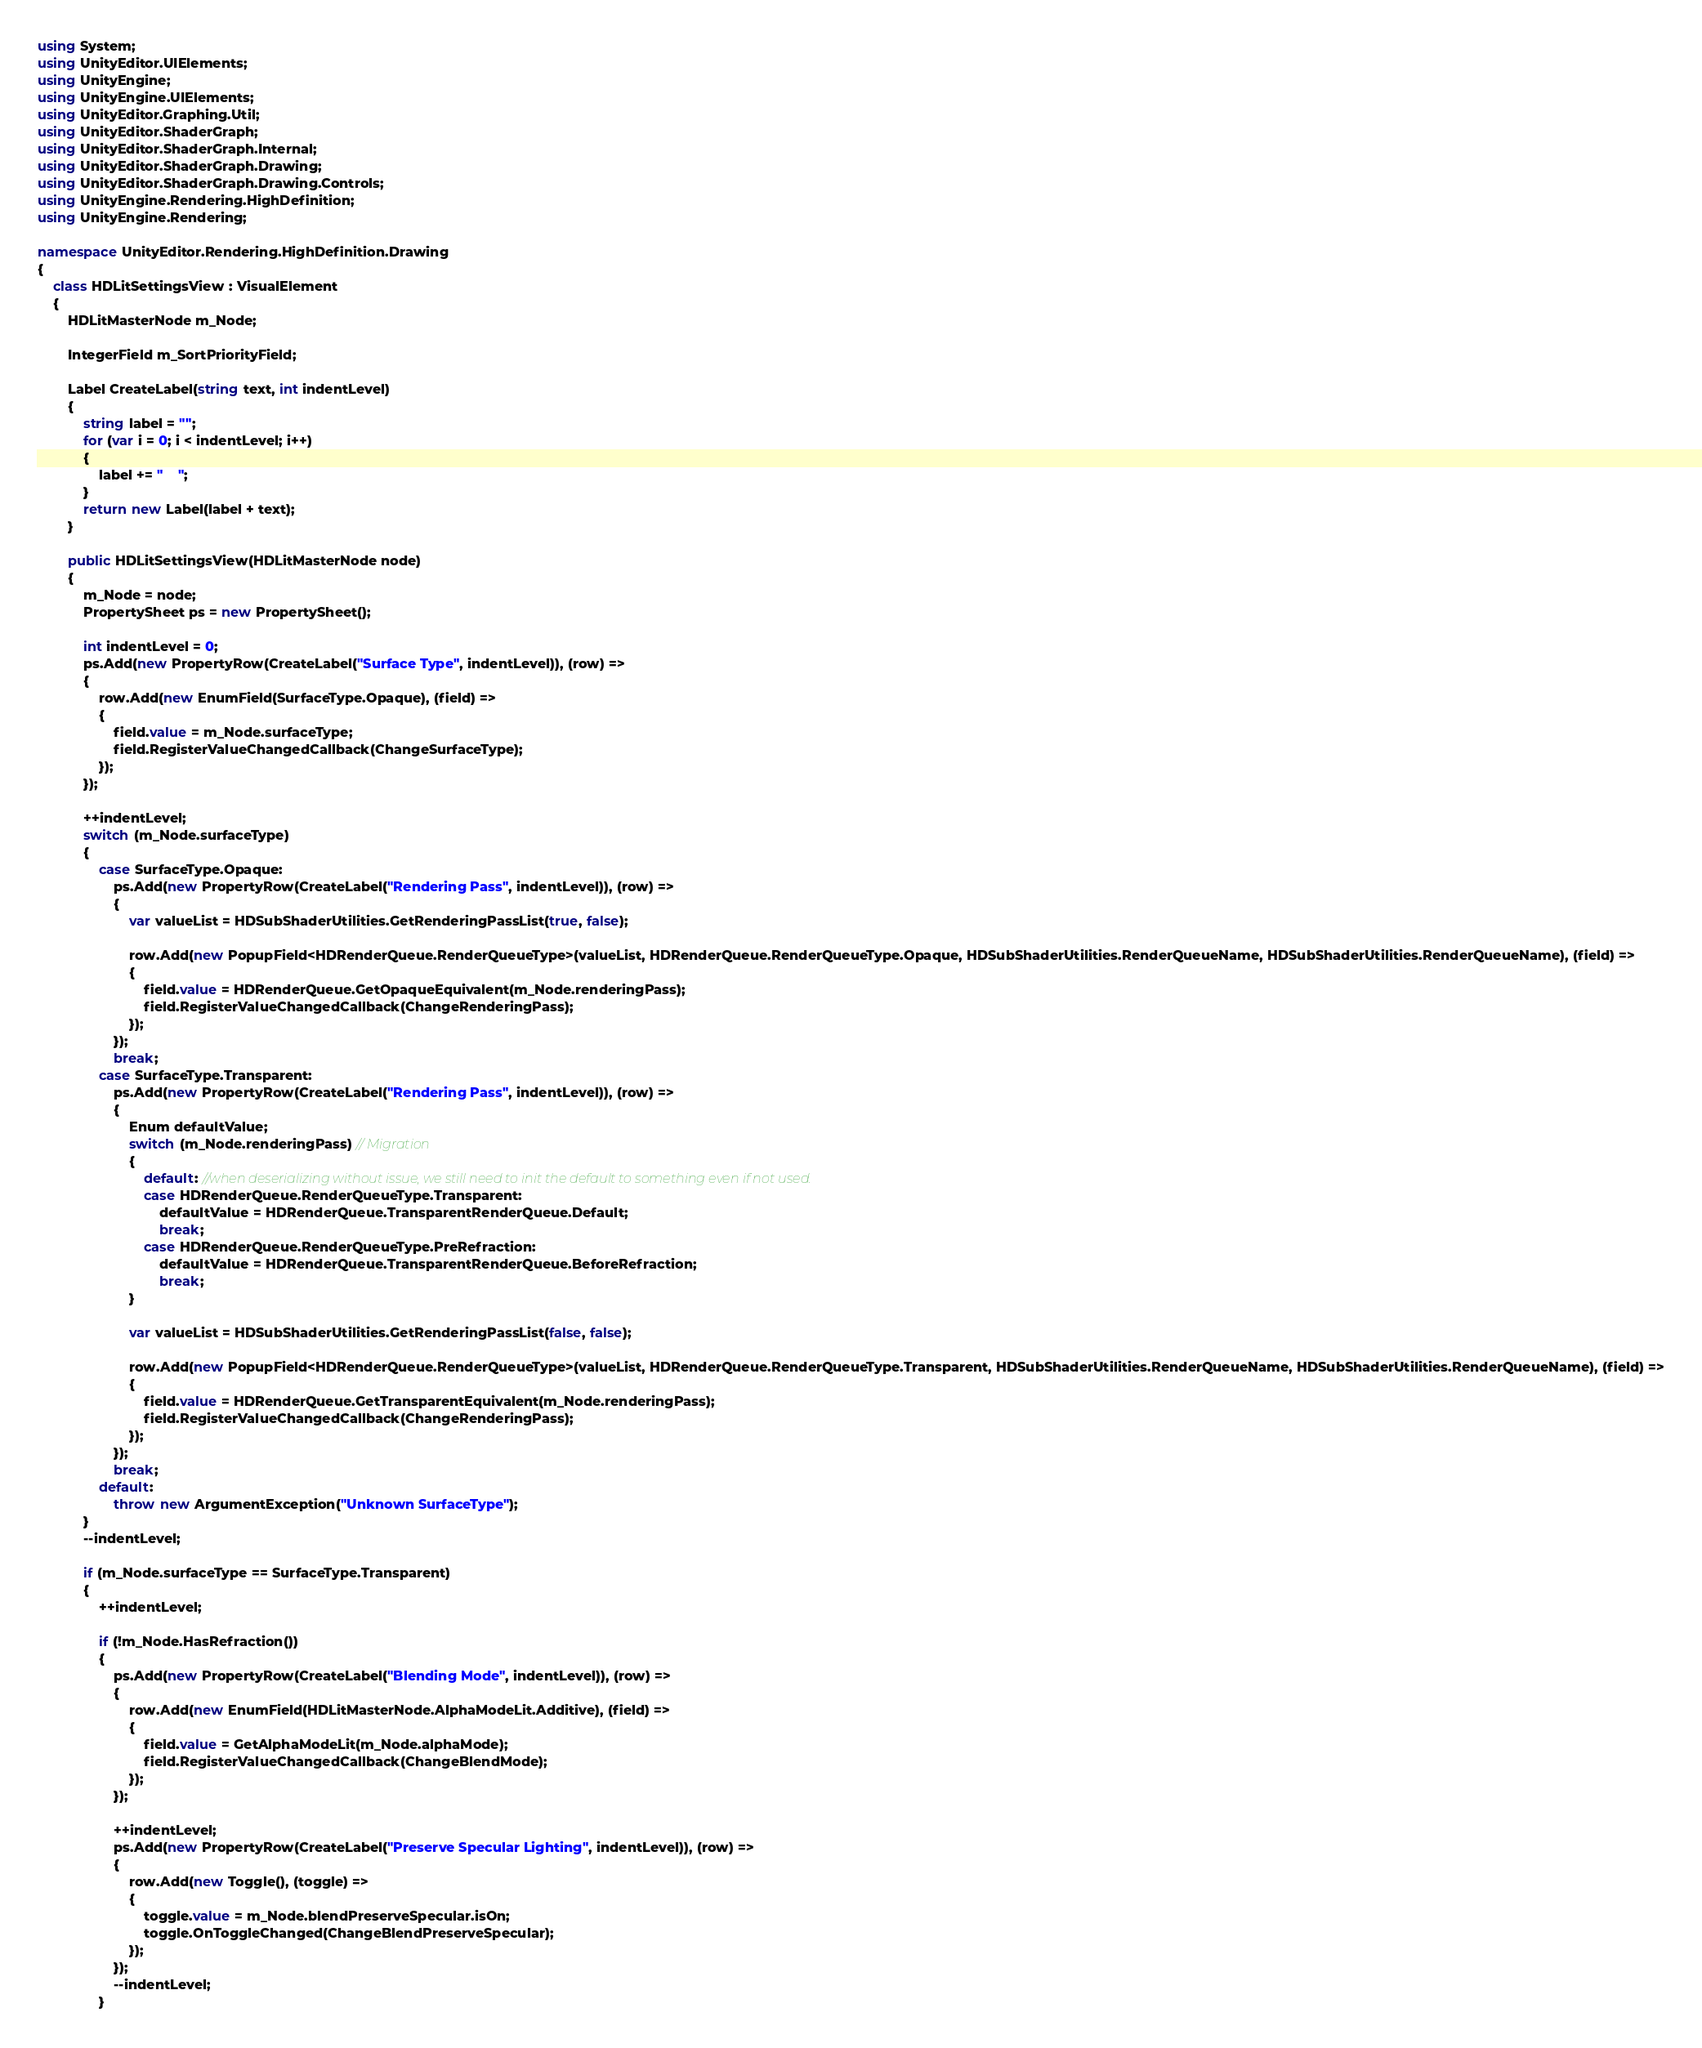<code> <loc_0><loc_0><loc_500><loc_500><_C#_>using System;
using UnityEditor.UIElements;
using UnityEngine;
using UnityEngine.UIElements;
using UnityEditor.Graphing.Util;
using UnityEditor.ShaderGraph;
using UnityEditor.ShaderGraph.Internal;
using UnityEditor.ShaderGraph.Drawing;
using UnityEditor.ShaderGraph.Drawing.Controls;
using UnityEngine.Rendering.HighDefinition;
using UnityEngine.Rendering;

namespace UnityEditor.Rendering.HighDefinition.Drawing
{
    class HDLitSettingsView : VisualElement
    {
        HDLitMasterNode m_Node;

        IntegerField m_SortPriorityField;

        Label CreateLabel(string text, int indentLevel)
        {
            string label = "";
            for (var i = 0; i < indentLevel; i++)
            {
                label += "    ";
            }
            return new Label(label + text);
        }

        public HDLitSettingsView(HDLitMasterNode node)
        {
            m_Node = node;
            PropertySheet ps = new PropertySheet();

            int indentLevel = 0;
            ps.Add(new PropertyRow(CreateLabel("Surface Type", indentLevel)), (row) =>
            {
                row.Add(new EnumField(SurfaceType.Opaque), (field) =>
                {
                    field.value = m_Node.surfaceType;
                    field.RegisterValueChangedCallback(ChangeSurfaceType);
                });
            });

            ++indentLevel;
            switch (m_Node.surfaceType)
            {
                case SurfaceType.Opaque:
                    ps.Add(new PropertyRow(CreateLabel("Rendering Pass", indentLevel)), (row) =>
                    {
                        var valueList = HDSubShaderUtilities.GetRenderingPassList(true, false);

                        row.Add(new PopupField<HDRenderQueue.RenderQueueType>(valueList, HDRenderQueue.RenderQueueType.Opaque, HDSubShaderUtilities.RenderQueueName, HDSubShaderUtilities.RenderQueueName), (field) =>
                        {
                            field.value = HDRenderQueue.GetOpaqueEquivalent(m_Node.renderingPass);
                            field.RegisterValueChangedCallback(ChangeRenderingPass);
                        });
                    });
                    break;
                case SurfaceType.Transparent:
                    ps.Add(new PropertyRow(CreateLabel("Rendering Pass", indentLevel)), (row) =>
                    {
                        Enum defaultValue;
                        switch (m_Node.renderingPass) // Migration
                        {
                            default: //when deserializing without issue, we still need to init the default to something even if not used.
                            case HDRenderQueue.RenderQueueType.Transparent:
                                defaultValue = HDRenderQueue.TransparentRenderQueue.Default;
                                break;
                            case HDRenderQueue.RenderQueueType.PreRefraction:
                                defaultValue = HDRenderQueue.TransparentRenderQueue.BeforeRefraction;
                                break;
                        }

                        var valueList = HDSubShaderUtilities.GetRenderingPassList(false, false);

                        row.Add(new PopupField<HDRenderQueue.RenderQueueType>(valueList, HDRenderQueue.RenderQueueType.Transparent, HDSubShaderUtilities.RenderQueueName, HDSubShaderUtilities.RenderQueueName), (field) =>
                        {
                            field.value = HDRenderQueue.GetTransparentEquivalent(m_Node.renderingPass);
                            field.RegisterValueChangedCallback(ChangeRenderingPass);
                        });
                    });
                    break;
                default:
                    throw new ArgumentException("Unknown SurfaceType");
            }
            --indentLevel;

            if (m_Node.surfaceType == SurfaceType.Transparent)
            {
                ++indentLevel;

                if (!m_Node.HasRefraction())
                {
                    ps.Add(new PropertyRow(CreateLabel("Blending Mode", indentLevel)), (row) =>
                    {
                        row.Add(new EnumField(HDLitMasterNode.AlphaModeLit.Additive), (field) =>
                        {
                            field.value = GetAlphaModeLit(m_Node.alphaMode);
                            field.RegisterValueChangedCallback(ChangeBlendMode);
                        });
                    });

                    ++indentLevel;
                    ps.Add(new PropertyRow(CreateLabel("Preserve Specular Lighting", indentLevel)), (row) =>
                    {
                        row.Add(new Toggle(), (toggle) =>
                        {
                            toggle.value = m_Node.blendPreserveSpecular.isOn;
                            toggle.OnToggleChanged(ChangeBlendPreserveSpecular);
                        });
                    });
                    --indentLevel;
                }
</code> 